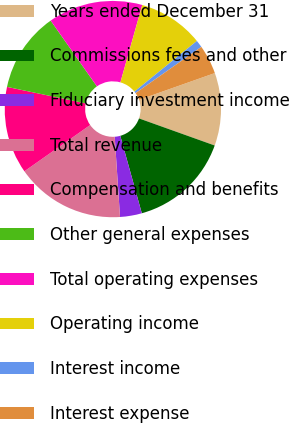<chart> <loc_0><loc_0><loc_500><loc_500><pie_chart><fcel>Years ended December 31<fcel>Commissions fees and other<fcel>Fiduciary investment income<fcel>Total revenue<fcel>Compensation and benefits<fcel>Other general expenses<fcel>Total operating expenses<fcel>Operating income<fcel>Interest income<fcel>Interest expense<nl><fcel>10.87%<fcel>15.22%<fcel>3.26%<fcel>16.3%<fcel>13.04%<fcel>11.96%<fcel>14.13%<fcel>9.78%<fcel>1.09%<fcel>4.35%<nl></chart> 